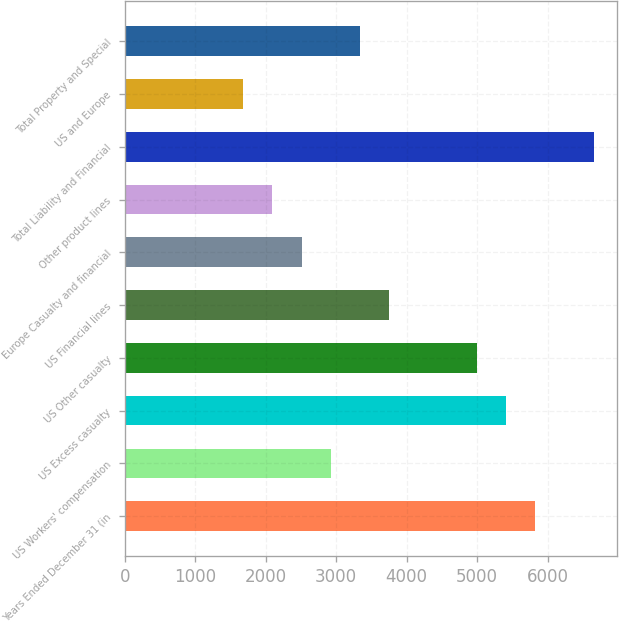Convert chart. <chart><loc_0><loc_0><loc_500><loc_500><bar_chart><fcel>Years Ended December 31 (in<fcel>US Workers' compensation<fcel>US Excess casualty<fcel>US Other casualty<fcel>US Financial lines<fcel>Europe Casualty and financial<fcel>Other product lines<fcel>Total Liability and Financial<fcel>US and Europe<fcel>Total Property and Special<nl><fcel>5828<fcel>2923<fcel>5413<fcel>4998<fcel>3753<fcel>2508<fcel>2093<fcel>6658<fcel>1678<fcel>3338<nl></chart> 